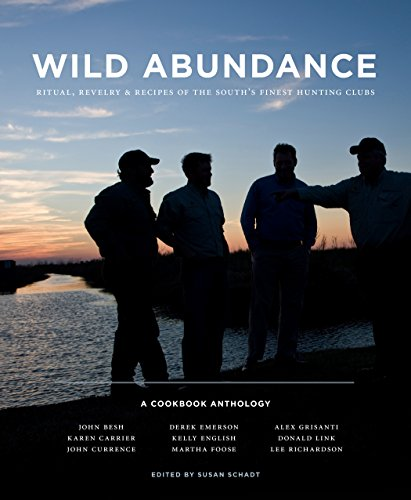What is the title of this book? The title of the book is 'Wild Abundance: Ritual, Revelry & Recipes of the South's Finest Hunting Clubs'. This engaging title hints at a rich exploration of culinary traditions mixed with cultural narratives from Southern hunting clubs. 